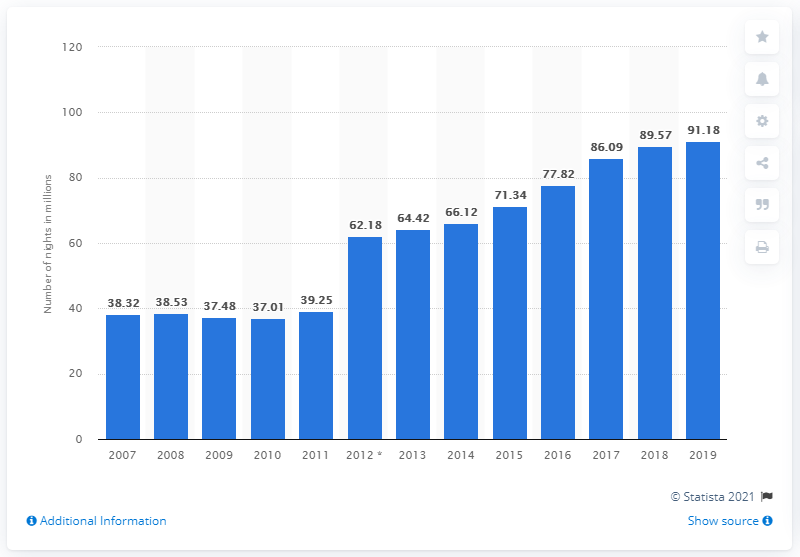Highlight a few significant elements in this photo. During the period of 2006 to 2019, a total of 91.18 nights were spent at tourist accommodation establishments in Croatia. 